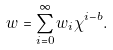<formula> <loc_0><loc_0><loc_500><loc_500>w = \sum _ { i = 0 } ^ { \infty } w _ { i } \chi ^ { i - b } .</formula> 